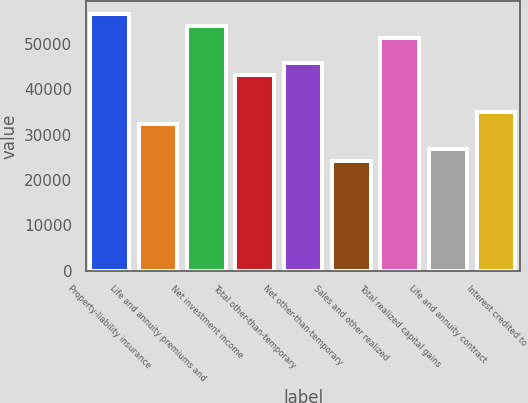Convert chart. <chart><loc_0><loc_0><loc_500><loc_500><bar_chart><fcel>Property-liability insurance<fcel>Life and annuity premiums and<fcel>Net investment income<fcel>Total other-than-temporary<fcel>Net other-than-temporary<fcel>Sales and other realized<fcel>Total realized capital gains<fcel>Life and annuity contract<fcel>Interest credited to<nl><fcel>56629<fcel>32360.1<fcel>53932.4<fcel>43146.3<fcel>45842.8<fcel>24270.5<fcel>51235.9<fcel>26967<fcel>35056.7<nl></chart> 